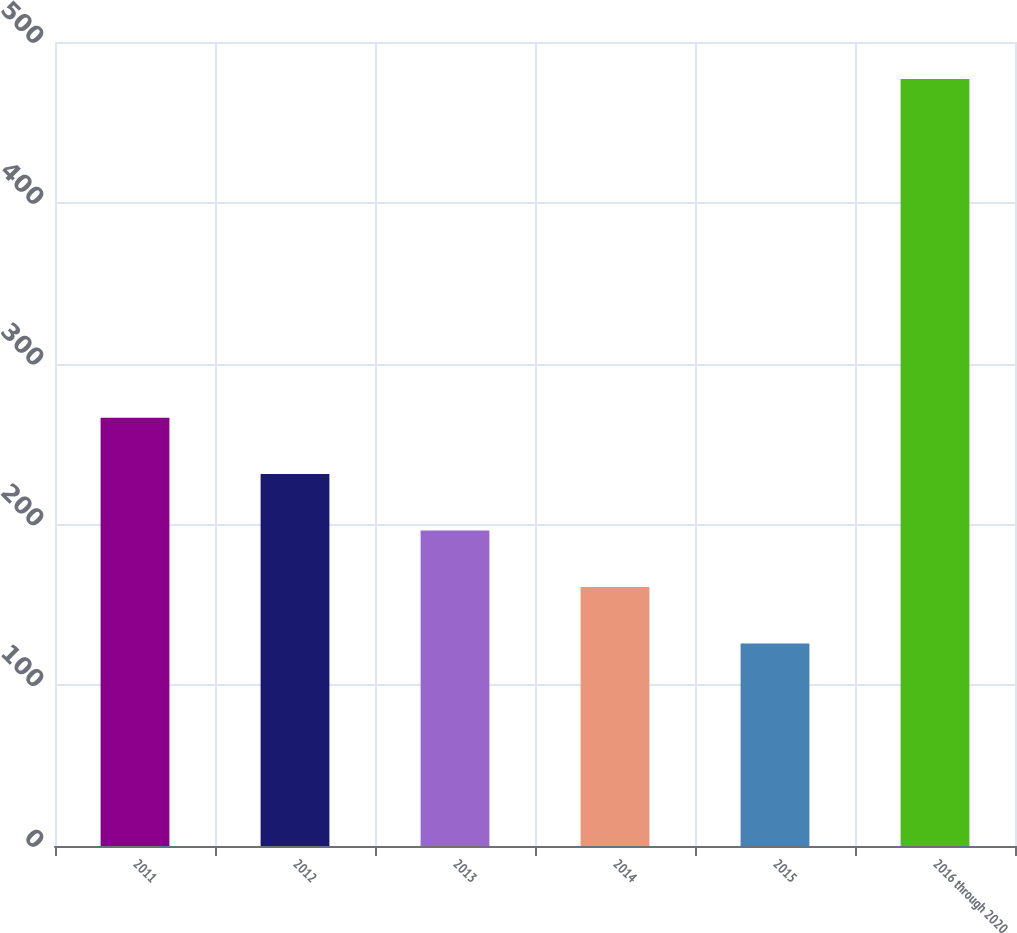Convert chart to OTSL. <chart><loc_0><loc_0><loc_500><loc_500><bar_chart><fcel>2011<fcel>2012<fcel>2013<fcel>2014<fcel>2015<fcel>2016 through 2020<nl><fcel>266.4<fcel>231.3<fcel>196.2<fcel>161.1<fcel>126<fcel>477<nl></chart> 